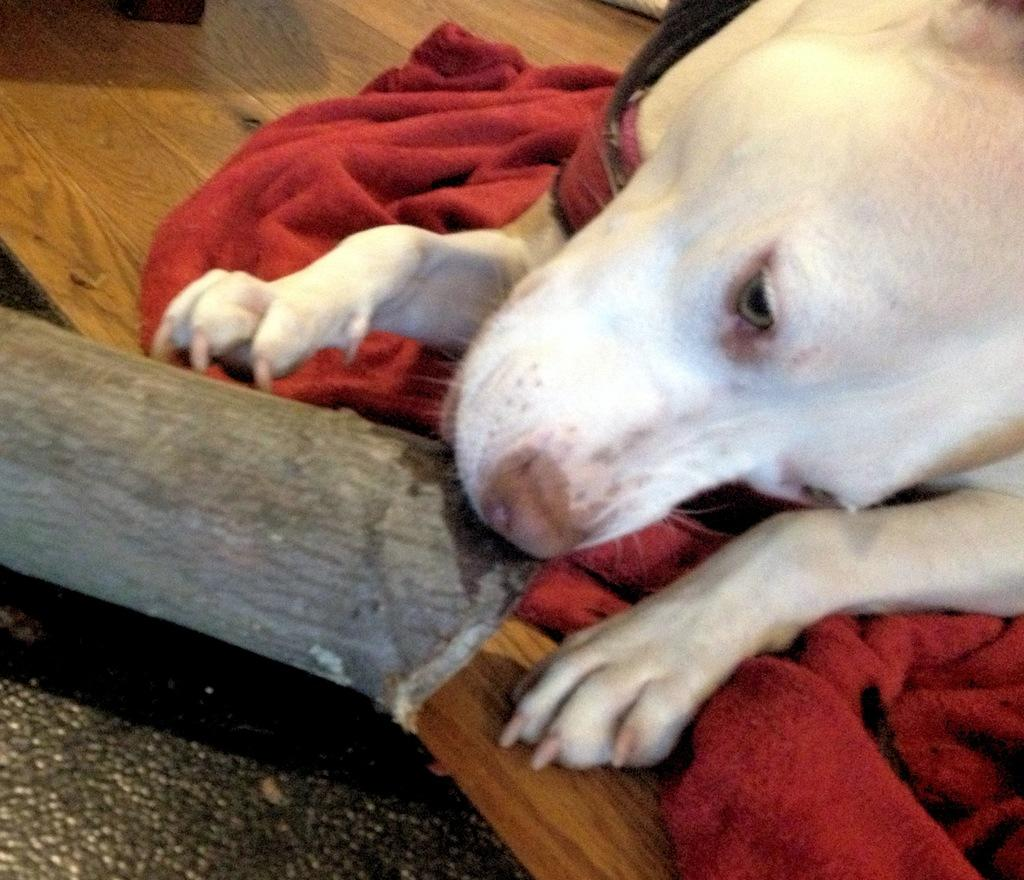What is the main subject of the image? The main subject of the image is a dog lying on the cloth. What can be seen on the left side of the image? There is a stick, a wooden surface, and a black object on the left side of the image. What type of badge is the dog wearing in the image? There is no badge present in the image; the dog is simply lying on the cloth. Can you tell me how many sofas are visible in the image? There are no sofas present in the image. 